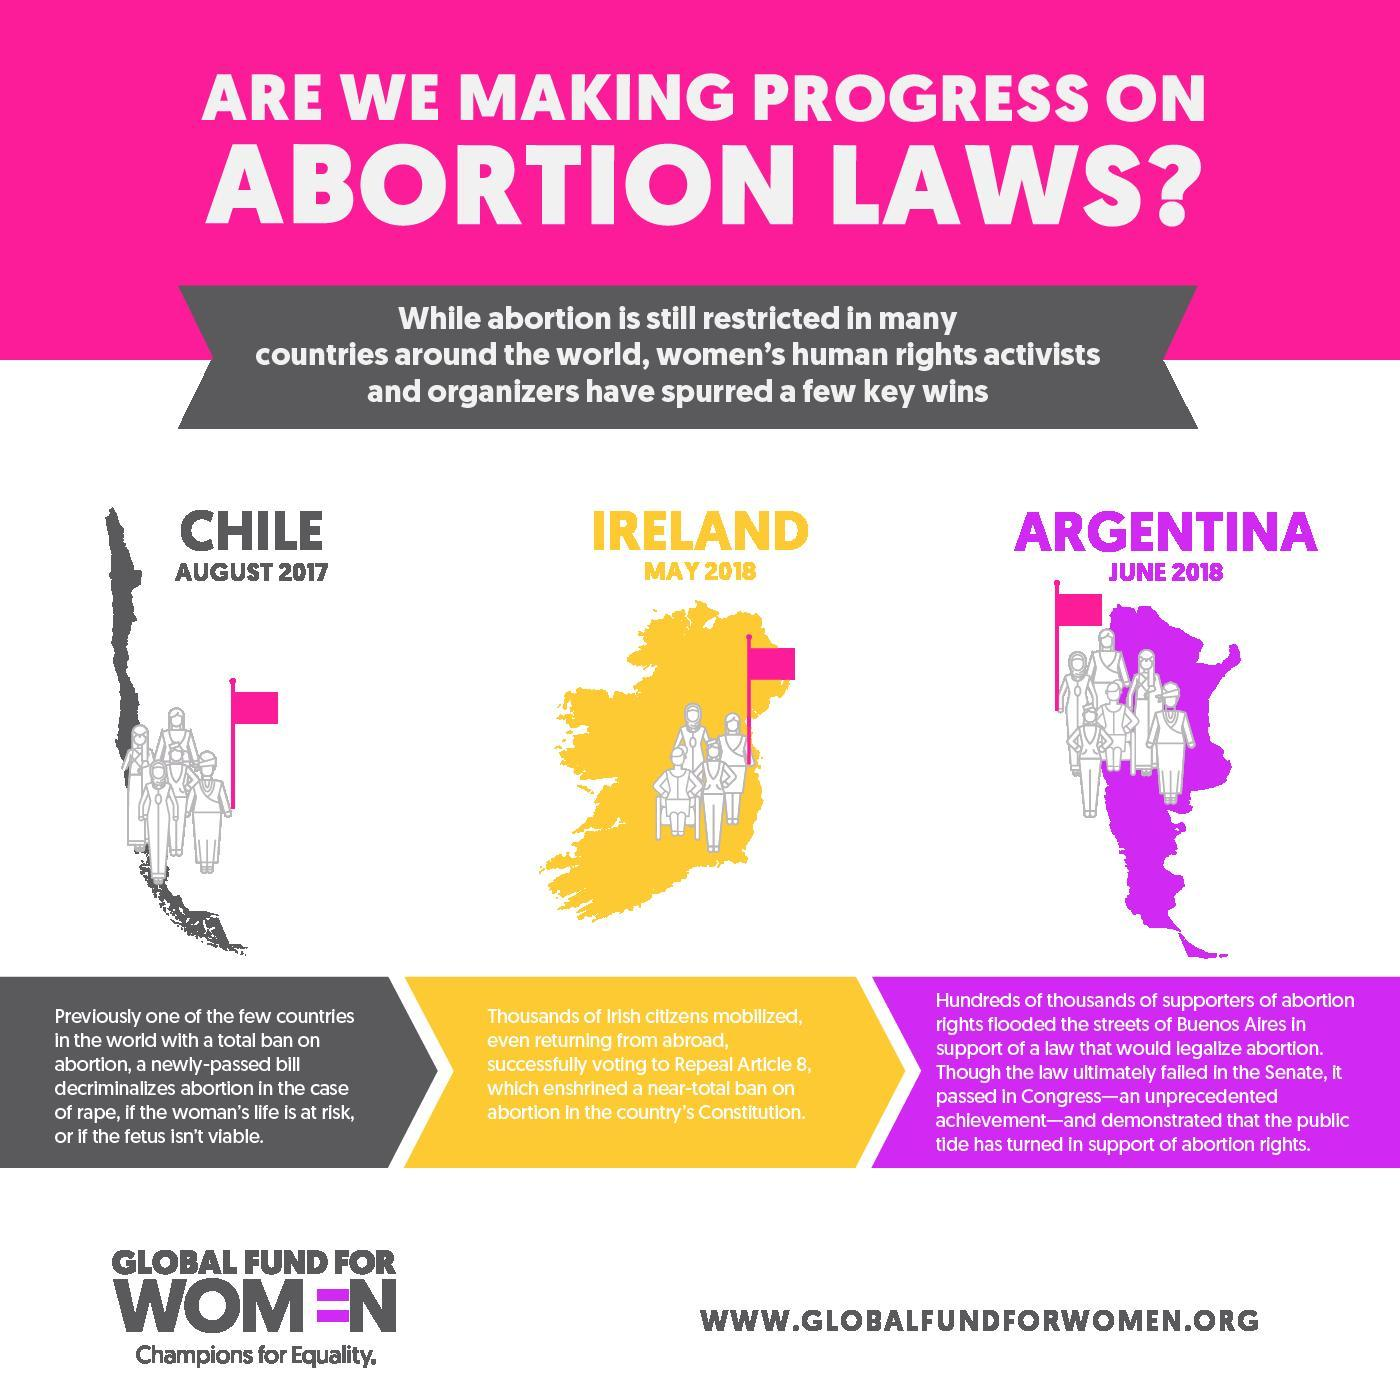Which country's abortion laws were changed in May 2018?
Answer the question with a short phrase. Ireland Which country decriminalized abortion for specific situations in August 2017? Chile Which country saw a huge public support for abortion rights in June 2018? Argentina 